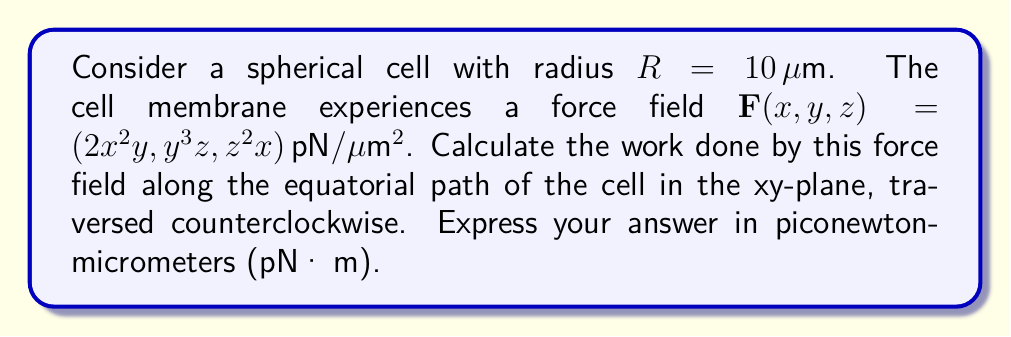Provide a solution to this math problem. To solve this problem, we'll follow these steps:

1) The equatorial path of the cell in the xy-plane is a circle with radius R = 10 μm. We can parameterize this path as:

   $x = R \cos t$, $y = R \sin t$, $z = 0$, where $0 \leq t \leq 2\pi$

2) The line integral for work is given by:

   $W = \oint_C \mathbf{F} \cdot d\mathbf{r}$

3) We need to express $d\mathbf{r}$ in terms of $t$:

   $d\mathbf{r} = (-R \sin t, R \cos t, 0) dt$

4) Now, let's evaluate $\mathbf{F}$ along the path:

   $\mathbf{F}(R \cos t, R \sin t, 0) = (2R^2 \cos^2 t \sin t, R^3 \sin^3 t, 0)$

5) The dot product $\mathbf{F} \cdot d\mathbf{r}$ is:

   $(2R^2 \cos^2 t \sin t)(-R \sin t) + (R^3 \sin^3 t)(R \cos t) = R^3 \sin^3 t \cos t - 2R^3 \cos^2 t \sin^2 t$

6) Now we can set up the integral:

   $W = \int_0^{2\pi} (R^3 \sin^3 t \cos t - 2R^3 \cos^2 t \sin^2 t) dt$

7) This can be simplified using trigonometric identities:

   $W = R^3 \int_0^{2\pi} (\frac{1}{4}\sin 4t - \frac{1}{2}\sin^2 2t) dt$

8) Evaluating this integral:

   $W = R^3 [\frac{1}{16}(-\cos 4t) - \frac{1}{4}t + \frac{1}{8}\sin 4t]_0^{2\pi} = -\frac{\pi}{2}R^3$

9) Substituting $R = 10 \mu m$:

   $W = -\frac{\pi}{2}(10^3) = -500\pi \, pN \cdot \mu m$
Answer: $-500\pi \, pN \cdot \mu m$ 